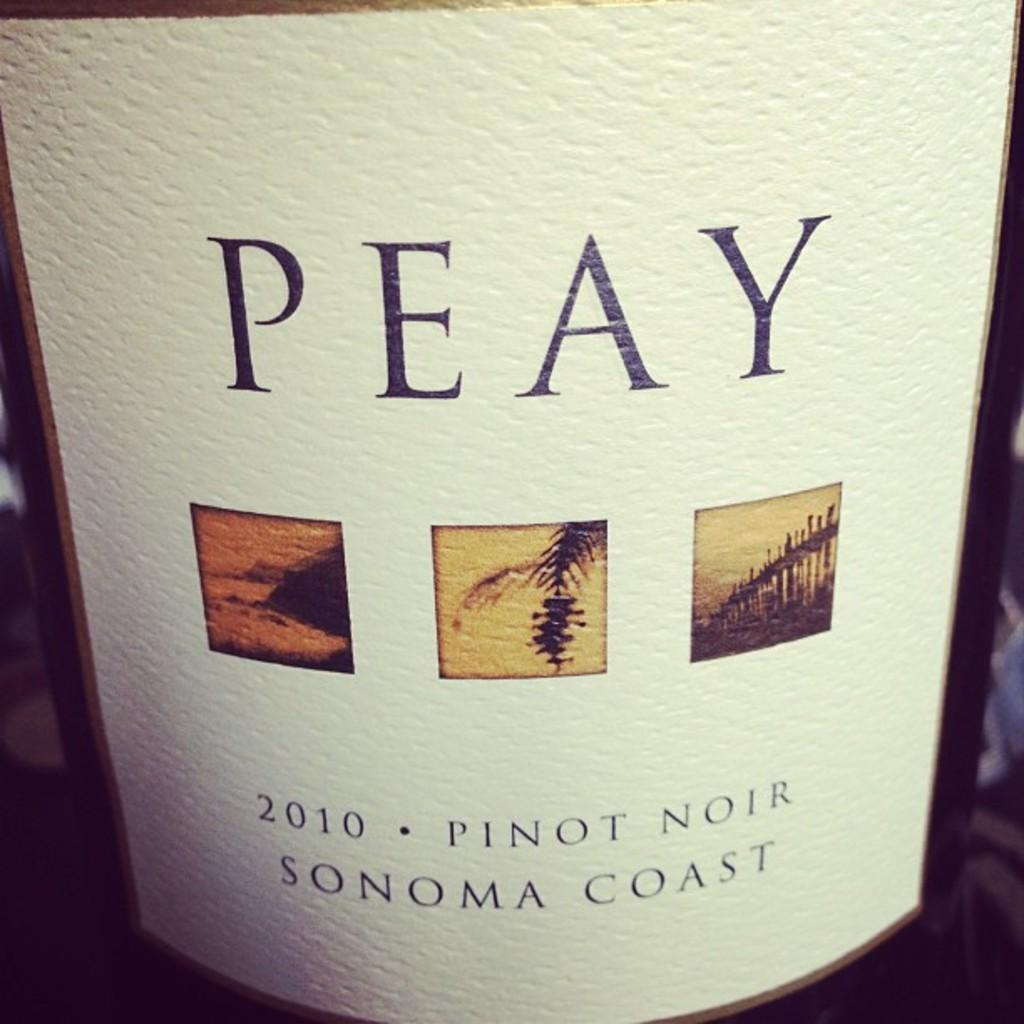<image>
Write a terse but informative summary of the picture. Peay Pinot Noir Sonoma Coast 2010 wine bottle 